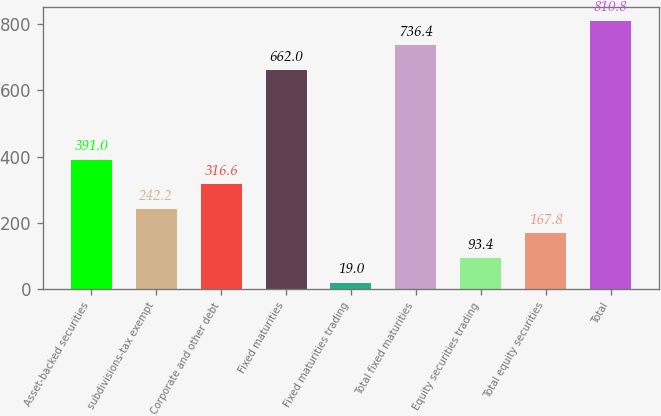<chart> <loc_0><loc_0><loc_500><loc_500><bar_chart><fcel>Asset-backed securities<fcel>subdivisions-tax exempt<fcel>Corporate and other debt<fcel>Fixed maturities<fcel>Fixed maturities trading<fcel>Total fixed maturities<fcel>Equity securities trading<fcel>Total equity securities<fcel>Total<nl><fcel>391<fcel>242.2<fcel>316.6<fcel>662<fcel>19<fcel>736.4<fcel>93.4<fcel>167.8<fcel>810.8<nl></chart> 